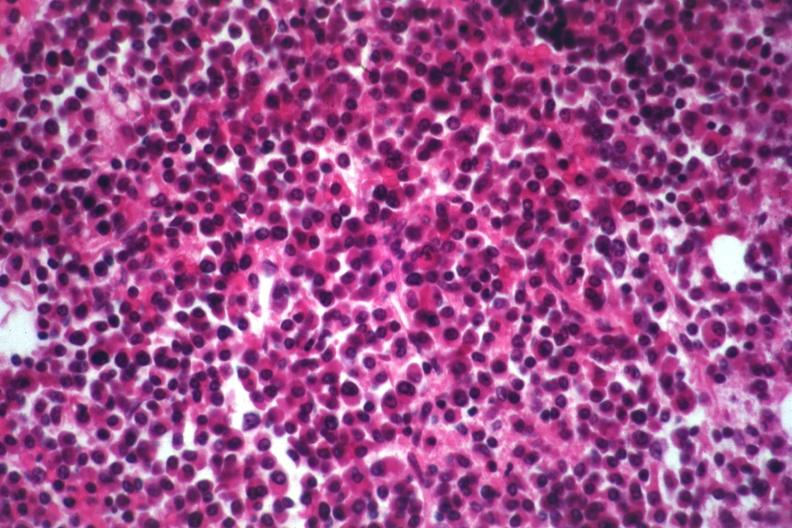what is present?
Answer the question using a single word or phrase. Bone marrow 